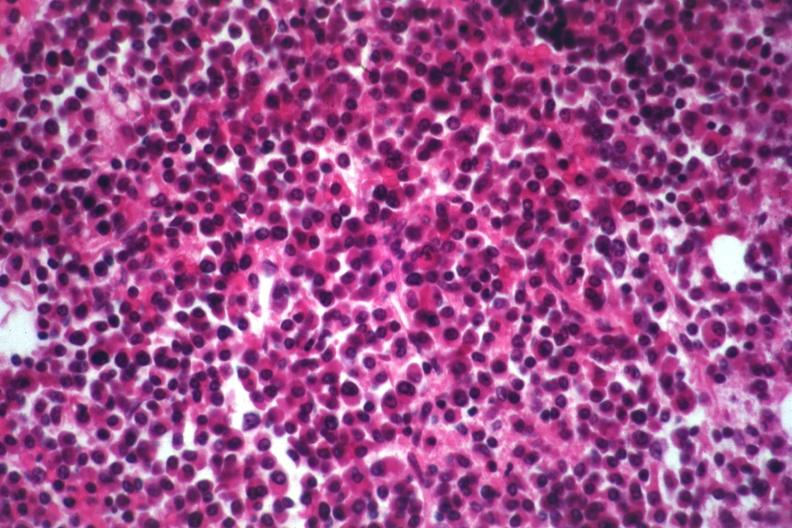what is present?
Answer the question using a single word or phrase. Bone marrow 